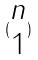Convert formula to latex. <formula><loc_0><loc_0><loc_500><loc_500>( \begin{matrix} n \\ 1 \end{matrix} )</formula> 